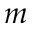Convert formula to latex. <formula><loc_0><loc_0><loc_500><loc_500>m</formula> 